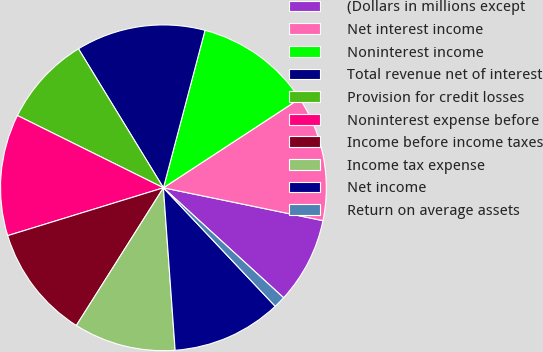<chart> <loc_0><loc_0><loc_500><loc_500><pie_chart><fcel>(Dollars in millions except<fcel>Net interest income<fcel>Noninterest income<fcel>Total revenue net of interest<fcel>Provision for credit losses<fcel>Noninterest expense before<fcel>Income before income taxes<fcel>Income tax expense<fcel>Net income<fcel>Return on average assets<nl><fcel>8.56%<fcel>12.45%<fcel>11.67%<fcel>12.84%<fcel>8.95%<fcel>12.06%<fcel>11.28%<fcel>10.12%<fcel>10.89%<fcel>1.17%<nl></chart> 